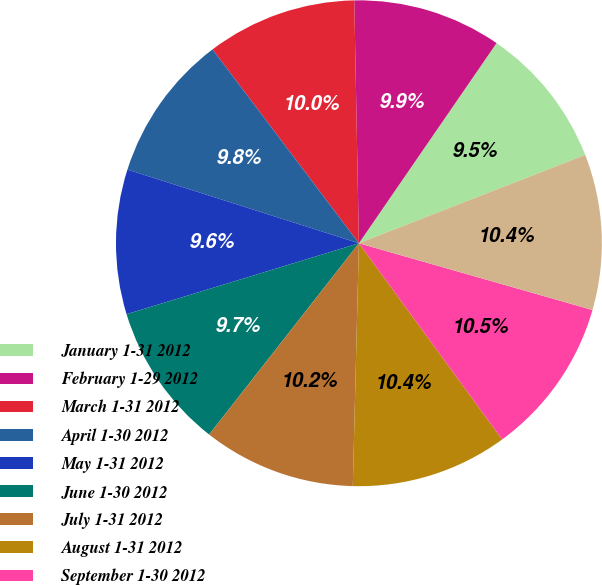Convert chart to OTSL. <chart><loc_0><loc_0><loc_500><loc_500><pie_chart><fcel>January 1-31 2012<fcel>February 1-29 2012<fcel>March 1-31 2012<fcel>April 1-30 2012<fcel>May 1-31 2012<fcel>June 1-30 2012<fcel>July 1-31 2012<fcel>August 1-31 2012<fcel>September 1-30 2012<fcel>October 1-31 2012<nl><fcel>9.49%<fcel>9.89%<fcel>9.99%<fcel>9.8%<fcel>9.62%<fcel>9.71%<fcel>10.17%<fcel>10.44%<fcel>10.53%<fcel>10.35%<nl></chart> 